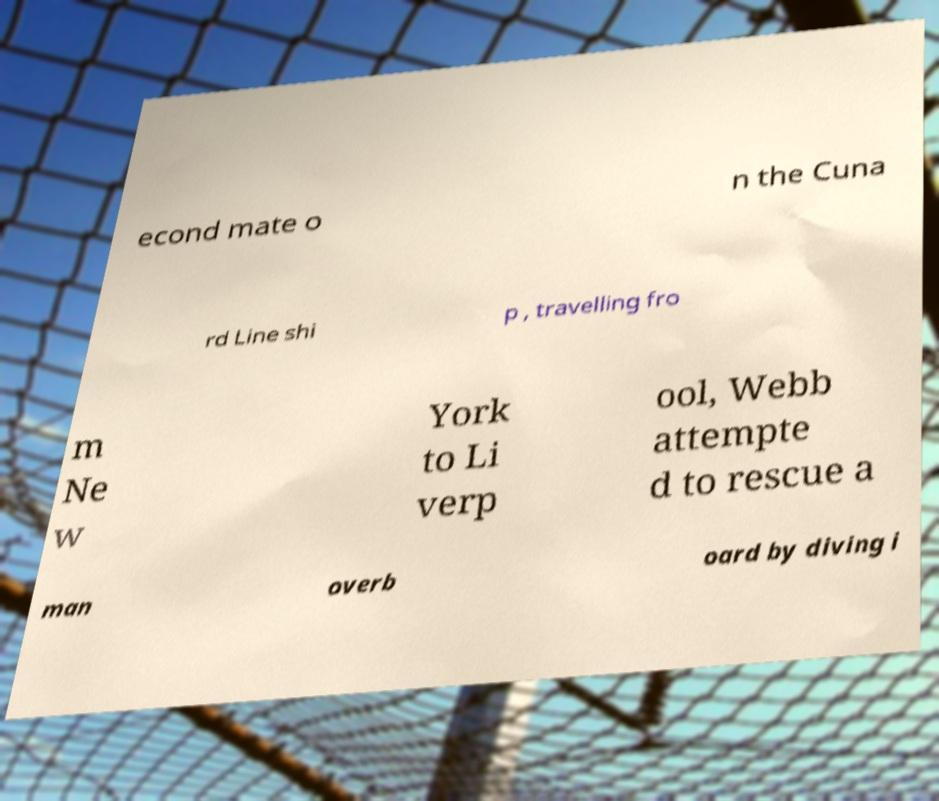Can you accurately transcribe the text from the provided image for me? econd mate o n the Cuna rd Line shi p , travelling fro m Ne w York to Li verp ool, Webb attempte d to rescue a man overb oard by diving i 